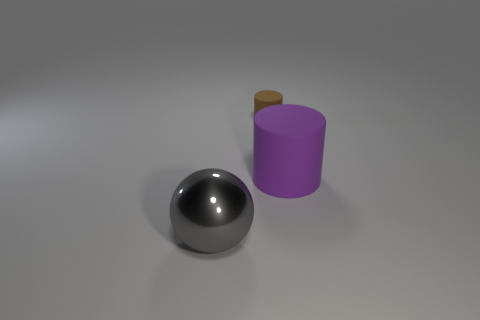Add 2 big cyan cubes. How many objects exist? 5 Subtract all cylinders. How many objects are left? 1 Add 1 brown matte objects. How many brown matte objects exist? 2 Subtract 0 green cylinders. How many objects are left? 3 Subtract all big green matte objects. Subtract all purple cylinders. How many objects are left? 2 Add 1 cylinders. How many cylinders are left? 3 